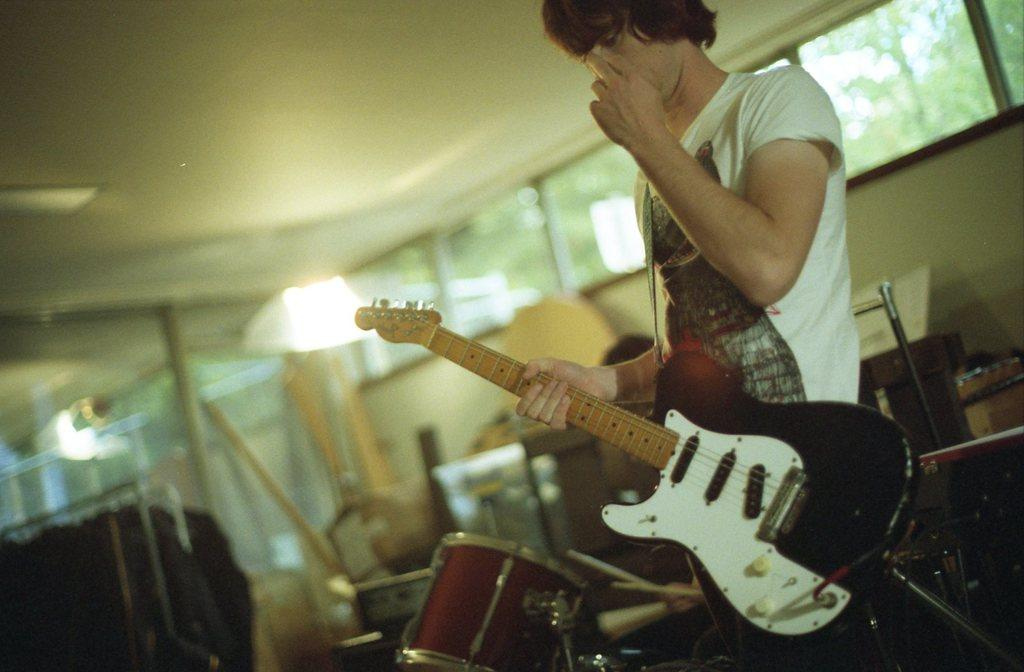What is the man in the image wearing? The man is wearing a white t-shirt. What is the man holding in the image? The man is holding a guitar. Can you describe the guitar's appearance? The guitar is red and white in color. What can be observed about the background of the image? The background of the image is blurry. What other musical instrument is present in the image? There is a musical drum beside the man. What might be used to play the musical drum? Sticks are present near the musical drum. How many fingers does the yak have in the image? There is no yak present in the image, so it is not possible to determine the number of fingers it might have. 